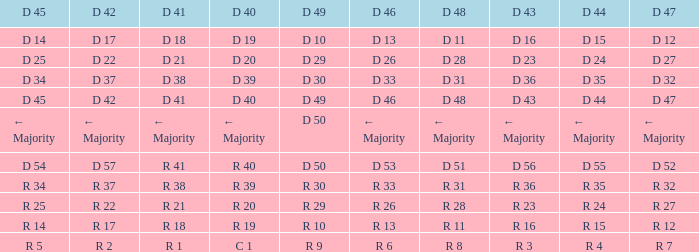I want the D 47 for D 41 being r 21 R 27. 